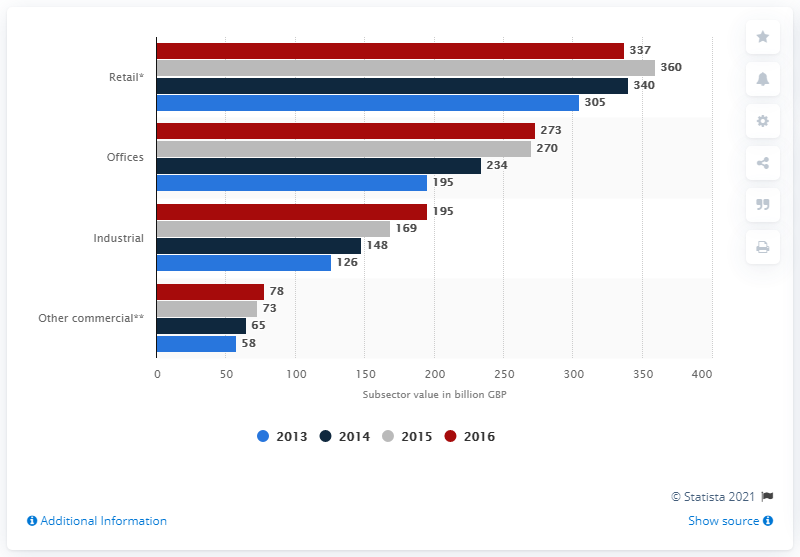Mention a couple of crucial points in this snapshot. In 2016, the market value of retail property was approximately 340... In 2015, the market value of retail property was approximately $360 million. 